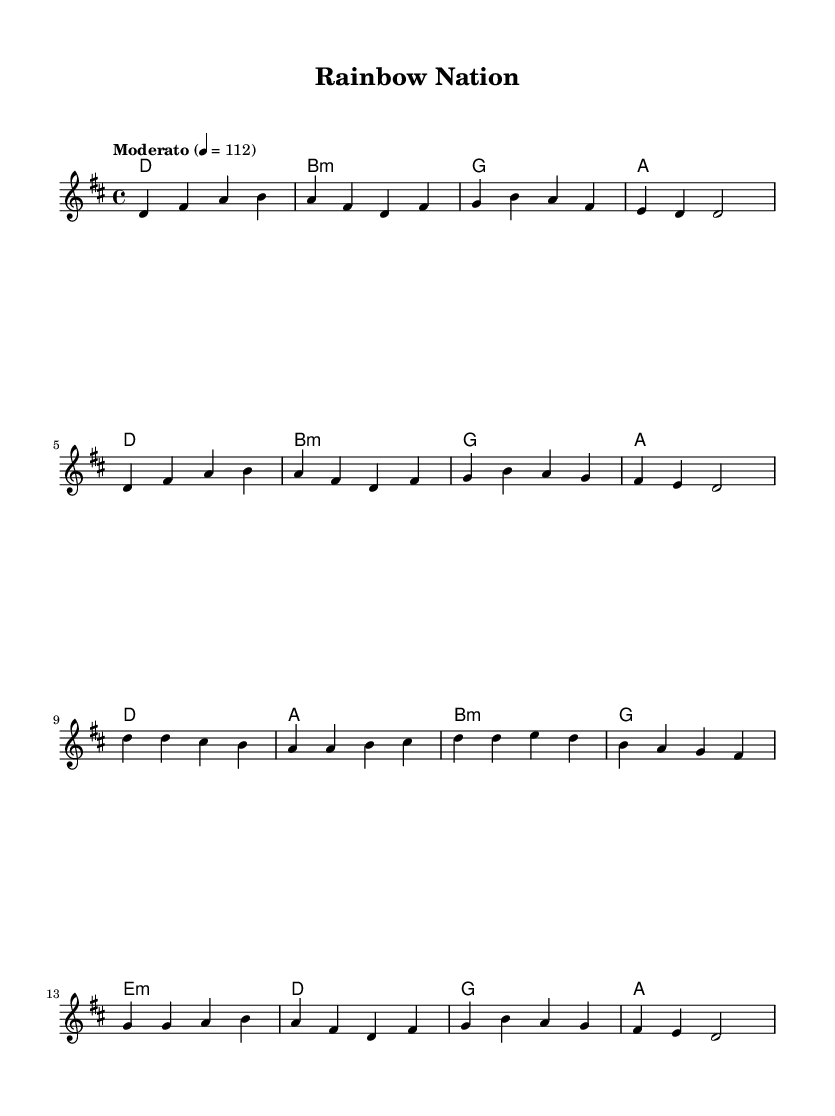What is the key signature of this music? The key signature displayed at the beginning indicates that the piece is in D major, which has two sharps (F# and C#).
Answer: D major What is the time signature of this music? The time signature is indicated by the fraction at the beginning, which shows that there are four beats per measure and the quarter note gets one beat.
Answer: 4/4 What is the tempo marking of the piece? The tempo marking is shown in Italian instructions and indicates that the piece should be played at a moderate speed of 112 beats per minute.
Answer: Moderato How many measures are there in the verse? By counting the number of measures in the verse section, it is noted that there are eight measures written before transitioning to the chorus.
Answer: 8 What chord follows the first measure of the chorus? By looking at the chord changes provided in the score, it can be seen that the chord after the first measure of the chorus is A major.
Answer: A How does this piece exemplify K-Pop characteristics? K-Pop often features catchy melodies and a blend of various musical styles; here, both the melodic and harmonic structures reflect that by utilizing familiar pop chord progressions and appealing melodic lines.
Answer: Catchy melodies What is the last chord of the piece? The last chord is found at the end of the score; examining the harmonies, the last chord written in the score is A major.
Answer: A 